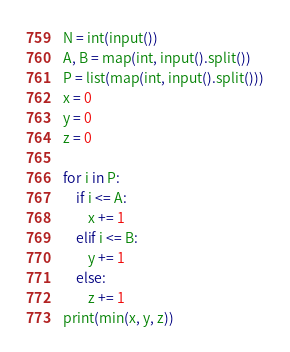<code> <loc_0><loc_0><loc_500><loc_500><_Python_>N = int(input())
A, B = map(int, input().split())
P = list(map(int, input().split()))
x = 0
y = 0
z = 0

for i in P:
    if i <= A:
        x += 1
    elif i <= B:
        y += 1
    else:
        z += 1
print(min(x, y, z))
</code> 